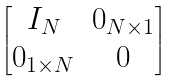Convert formula to latex. <formula><loc_0><loc_0><loc_500><loc_500>\begin{bmatrix} I _ { N } & 0 _ { N \times 1 } \\ 0 _ { 1 \times N } & 0 \end{bmatrix}</formula> 